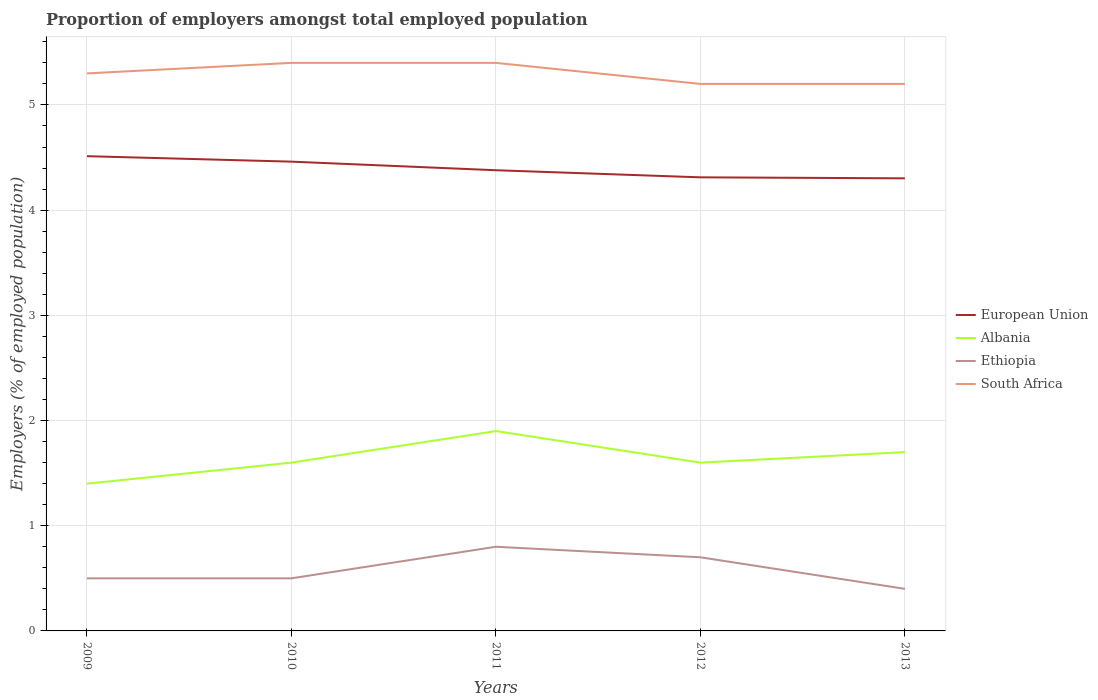How many different coloured lines are there?
Your response must be concise. 4. Across all years, what is the maximum proportion of employers in Albania?
Ensure brevity in your answer.  1.4. In which year was the proportion of employers in Albania maximum?
Your response must be concise. 2009. What is the difference between the highest and the second highest proportion of employers in Albania?
Give a very brief answer. 0.5. Is the proportion of employers in Albania strictly greater than the proportion of employers in South Africa over the years?
Provide a succinct answer. Yes. How many lines are there?
Your answer should be very brief. 4. Are the values on the major ticks of Y-axis written in scientific E-notation?
Ensure brevity in your answer.  No. Does the graph contain any zero values?
Provide a short and direct response. No. Where does the legend appear in the graph?
Ensure brevity in your answer.  Center right. How are the legend labels stacked?
Ensure brevity in your answer.  Vertical. What is the title of the graph?
Provide a short and direct response. Proportion of employers amongst total employed population. Does "Pakistan" appear as one of the legend labels in the graph?
Your response must be concise. No. What is the label or title of the X-axis?
Ensure brevity in your answer.  Years. What is the label or title of the Y-axis?
Ensure brevity in your answer.  Employers (% of employed population). What is the Employers (% of employed population) of European Union in 2009?
Your response must be concise. 4.51. What is the Employers (% of employed population) in Albania in 2009?
Offer a terse response. 1.4. What is the Employers (% of employed population) in Ethiopia in 2009?
Your answer should be very brief. 0.5. What is the Employers (% of employed population) in South Africa in 2009?
Make the answer very short. 5.3. What is the Employers (% of employed population) of European Union in 2010?
Provide a succinct answer. 4.46. What is the Employers (% of employed population) of Albania in 2010?
Your response must be concise. 1.6. What is the Employers (% of employed population) of Ethiopia in 2010?
Offer a terse response. 0.5. What is the Employers (% of employed population) of South Africa in 2010?
Your answer should be compact. 5.4. What is the Employers (% of employed population) in European Union in 2011?
Keep it short and to the point. 4.38. What is the Employers (% of employed population) in Albania in 2011?
Your answer should be very brief. 1.9. What is the Employers (% of employed population) in Ethiopia in 2011?
Give a very brief answer. 0.8. What is the Employers (% of employed population) in South Africa in 2011?
Make the answer very short. 5.4. What is the Employers (% of employed population) of European Union in 2012?
Make the answer very short. 4.31. What is the Employers (% of employed population) in Albania in 2012?
Your response must be concise. 1.6. What is the Employers (% of employed population) in Ethiopia in 2012?
Offer a terse response. 0.7. What is the Employers (% of employed population) in South Africa in 2012?
Provide a succinct answer. 5.2. What is the Employers (% of employed population) of European Union in 2013?
Ensure brevity in your answer.  4.3. What is the Employers (% of employed population) in Albania in 2013?
Give a very brief answer. 1.7. What is the Employers (% of employed population) in Ethiopia in 2013?
Your answer should be compact. 0.4. What is the Employers (% of employed population) in South Africa in 2013?
Offer a terse response. 5.2. Across all years, what is the maximum Employers (% of employed population) of European Union?
Give a very brief answer. 4.51. Across all years, what is the maximum Employers (% of employed population) of Albania?
Provide a short and direct response. 1.9. Across all years, what is the maximum Employers (% of employed population) of Ethiopia?
Offer a very short reply. 0.8. Across all years, what is the maximum Employers (% of employed population) of South Africa?
Your response must be concise. 5.4. Across all years, what is the minimum Employers (% of employed population) in European Union?
Offer a terse response. 4.3. Across all years, what is the minimum Employers (% of employed population) in Albania?
Offer a terse response. 1.4. Across all years, what is the minimum Employers (% of employed population) of Ethiopia?
Your answer should be very brief. 0.4. Across all years, what is the minimum Employers (% of employed population) in South Africa?
Your answer should be very brief. 5.2. What is the total Employers (% of employed population) of European Union in the graph?
Offer a terse response. 21.97. What is the difference between the Employers (% of employed population) of European Union in 2009 and that in 2010?
Your response must be concise. 0.05. What is the difference between the Employers (% of employed population) in Ethiopia in 2009 and that in 2010?
Your answer should be compact. 0. What is the difference between the Employers (% of employed population) of European Union in 2009 and that in 2011?
Make the answer very short. 0.13. What is the difference between the Employers (% of employed population) in Albania in 2009 and that in 2011?
Provide a short and direct response. -0.5. What is the difference between the Employers (% of employed population) in European Union in 2009 and that in 2012?
Provide a succinct answer. 0.2. What is the difference between the Employers (% of employed population) in South Africa in 2009 and that in 2012?
Make the answer very short. 0.1. What is the difference between the Employers (% of employed population) in European Union in 2009 and that in 2013?
Offer a terse response. 0.21. What is the difference between the Employers (% of employed population) of Ethiopia in 2009 and that in 2013?
Give a very brief answer. 0.1. What is the difference between the Employers (% of employed population) in South Africa in 2009 and that in 2013?
Keep it short and to the point. 0.1. What is the difference between the Employers (% of employed population) in European Union in 2010 and that in 2011?
Ensure brevity in your answer.  0.08. What is the difference between the Employers (% of employed population) of Ethiopia in 2010 and that in 2011?
Ensure brevity in your answer.  -0.3. What is the difference between the Employers (% of employed population) of European Union in 2010 and that in 2012?
Offer a very short reply. 0.15. What is the difference between the Employers (% of employed population) of Albania in 2010 and that in 2012?
Your answer should be compact. 0. What is the difference between the Employers (% of employed population) of Ethiopia in 2010 and that in 2012?
Keep it short and to the point. -0.2. What is the difference between the Employers (% of employed population) of European Union in 2010 and that in 2013?
Keep it short and to the point. 0.16. What is the difference between the Employers (% of employed population) in Ethiopia in 2010 and that in 2013?
Your answer should be compact. 0.1. What is the difference between the Employers (% of employed population) of European Union in 2011 and that in 2012?
Make the answer very short. 0.07. What is the difference between the Employers (% of employed population) of South Africa in 2011 and that in 2012?
Keep it short and to the point. 0.2. What is the difference between the Employers (% of employed population) in European Union in 2011 and that in 2013?
Your answer should be very brief. 0.08. What is the difference between the Employers (% of employed population) of South Africa in 2011 and that in 2013?
Offer a terse response. 0.2. What is the difference between the Employers (% of employed population) in European Union in 2012 and that in 2013?
Your answer should be compact. 0.01. What is the difference between the Employers (% of employed population) of Ethiopia in 2012 and that in 2013?
Your answer should be very brief. 0.3. What is the difference between the Employers (% of employed population) in South Africa in 2012 and that in 2013?
Provide a succinct answer. 0. What is the difference between the Employers (% of employed population) in European Union in 2009 and the Employers (% of employed population) in Albania in 2010?
Your response must be concise. 2.91. What is the difference between the Employers (% of employed population) in European Union in 2009 and the Employers (% of employed population) in Ethiopia in 2010?
Your answer should be compact. 4.01. What is the difference between the Employers (% of employed population) in European Union in 2009 and the Employers (% of employed population) in South Africa in 2010?
Your answer should be compact. -0.89. What is the difference between the Employers (% of employed population) in Albania in 2009 and the Employers (% of employed population) in Ethiopia in 2010?
Provide a succinct answer. 0.9. What is the difference between the Employers (% of employed population) in Albania in 2009 and the Employers (% of employed population) in South Africa in 2010?
Offer a terse response. -4. What is the difference between the Employers (% of employed population) in Ethiopia in 2009 and the Employers (% of employed population) in South Africa in 2010?
Provide a succinct answer. -4.9. What is the difference between the Employers (% of employed population) in European Union in 2009 and the Employers (% of employed population) in Albania in 2011?
Give a very brief answer. 2.61. What is the difference between the Employers (% of employed population) of European Union in 2009 and the Employers (% of employed population) of Ethiopia in 2011?
Your answer should be very brief. 3.71. What is the difference between the Employers (% of employed population) of European Union in 2009 and the Employers (% of employed population) of South Africa in 2011?
Provide a short and direct response. -0.89. What is the difference between the Employers (% of employed population) in Albania in 2009 and the Employers (% of employed population) in South Africa in 2011?
Make the answer very short. -4. What is the difference between the Employers (% of employed population) in Ethiopia in 2009 and the Employers (% of employed population) in South Africa in 2011?
Provide a short and direct response. -4.9. What is the difference between the Employers (% of employed population) of European Union in 2009 and the Employers (% of employed population) of Albania in 2012?
Offer a very short reply. 2.91. What is the difference between the Employers (% of employed population) of European Union in 2009 and the Employers (% of employed population) of Ethiopia in 2012?
Offer a very short reply. 3.81. What is the difference between the Employers (% of employed population) of European Union in 2009 and the Employers (% of employed population) of South Africa in 2012?
Keep it short and to the point. -0.69. What is the difference between the Employers (% of employed population) of Ethiopia in 2009 and the Employers (% of employed population) of South Africa in 2012?
Give a very brief answer. -4.7. What is the difference between the Employers (% of employed population) of European Union in 2009 and the Employers (% of employed population) of Albania in 2013?
Ensure brevity in your answer.  2.81. What is the difference between the Employers (% of employed population) in European Union in 2009 and the Employers (% of employed population) in Ethiopia in 2013?
Your answer should be compact. 4.11. What is the difference between the Employers (% of employed population) of European Union in 2009 and the Employers (% of employed population) of South Africa in 2013?
Keep it short and to the point. -0.69. What is the difference between the Employers (% of employed population) in Albania in 2009 and the Employers (% of employed population) in South Africa in 2013?
Your answer should be very brief. -3.8. What is the difference between the Employers (% of employed population) of Ethiopia in 2009 and the Employers (% of employed population) of South Africa in 2013?
Provide a succinct answer. -4.7. What is the difference between the Employers (% of employed population) of European Union in 2010 and the Employers (% of employed population) of Albania in 2011?
Your response must be concise. 2.56. What is the difference between the Employers (% of employed population) in European Union in 2010 and the Employers (% of employed population) in Ethiopia in 2011?
Offer a terse response. 3.66. What is the difference between the Employers (% of employed population) in European Union in 2010 and the Employers (% of employed population) in South Africa in 2011?
Your answer should be compact. -0.94. What is the difference between the Employers (% of employed population) in Albania in 2010 and the Employers (% of employed population) in South Africa in 2011?
Give a very brief answer. -3.8. What is the difference between the Employers (% of employed population) in Ethiopia in 2010 and the Employers (% of employed population) in South Africa in 2011?
Your answer should be compact. -4.9. What is the difference between the Employers (% of employed population) in European Union in 2010 and the Employers (% of employed population) in Albania in 2012?
Keep it short and to the point. 2.86. What is the difference between the Employers (% of employed population) of European Union in 2010 and the Employers (% of employed population) of Ethiopia in 2012?
Offer a very short reply. 3.76. What is the difference between the Employers (% of employed population) of European Union in 2010 and the Employers (% of employed population) of South Africa in 2012?
Your response must be concise. -0.74. What is the difference between the Employers (% of employed population) in Albania in 2010 and the Employers (% of employed population) in Ethiopia in 2012?
Give a very brief answer. 0.9. What is the difference between the Employers (% of employed population) of Albania in 2010 and the Employers (% of employed population) of South Africa in 2012?
Provide a succinct answer. -3.6. What is the difference between the Employers (% of employed population) of European Union in 2010 and the Employers (% of employed population) of Albania in 2013?
Provide a succinct answer. 2.76. What is the difference between the Employers (% of employed population) of European Union in 2010 and the Employers (% of employed population) of Ethiopia in 2013?
Provide a succinct answer. 4.06. What is the difference between the Employers (% of employed population) in European Union in 2010 and the Employers (% of employed population) in South Africa in 2013?
Give a very brief answer. -0.74. What is the difference between the Employers (% of employed population) of Albania in 2010 and the Employers (% of employed population) of South Africa in 2013?
Give a very brief answer. -3.6. What is the difference between the Employers (% of employed population) of Ethiopia in 2010 and the Employers (% of employed population) of South Africa in 2013?
Offer a very short reply. -4.7. What is the difference between the Employers (% of employed population) in European Union in 2011 and the Employers (% of employed population) in Albania in 2012?
Offer a terse response. 2.78. What is the difference between the Employers (% of employed population) in European Union in 2011 and the Employers (% of employed population) in Ethiopia in 2012?
Ensure brevity in your answer.  3.68. What is the difference between the Employers (% of employed population) of European Union in 2011 and the Employers (% of employed population) of South Africa in 2012?
Provide a succinct answer. -0.82. What is the difference between the Employers (% of employed population) in Ethiopia in 2011 and the Employers (% of employed population) in South Africa in 2012?
Provide a succinct answer. -4.4. What is the difference between the Employers (% of employed population) of European Union in 2011 and the Employers (% of employed population) of Albania in 2013?
Offer a terse response. 2.68. What is the difference between the Employers (% of employed population) in European Union in 2011 and the Employers (% of employed population) in Ethiopia in 2013?
Ensure brevity in your answer.  3.98. What is the difference between the Employers (% of employed population) of European Union in 2011 and the Employers (% of employed population) of South Africa in 2013?
Ensure brevity in your answer.  -0.82. What is the difference between the Employers (% of employed population) of Albania in 2011 and the Employers (% of employed population) of Ethiopia in 2013?
Provide a short and direct response. 1.5. What is the difference between the Employers (% of employed population) of European Union in 2012 and the Employers (% of employed population) of Albania in 2013?
Your response must be concise. 2.61. What is the difference between the Employers (% of employed population) of European Union in 2012 and the Employers (% of employed population) of Ethiopia in 2013?
Ensure brevity in your answer.  3.91. What is the difference between the Employers (% of employed population) in European Union in 2012 and the Employers (% of employed population) in South Africa in 2013?
Your response must be concise. -0.89. What is the difference between the Employers (% of employed population) in Albania in 2012 and the Employers (% of employed population) in Ethiopia in 2013?
Offer a terse response. 1.2. What is the difference between the Employers (% of employed population) of Albania in 2012 and the Employers (% of employed population) of South Africa in 2013?
Keep it short and to the point. -3.6. What is the average Employers (% of employed population) in European Union per year?
Ensure brevity in your answer.  4.39. What is the average Employers (% of employed population) in Albania per year?
Offer a terse response. 1.64. What is the average Employers (% of employed population) in Ethiopia per year?
Ensure brevity in your answer.  0.58. In the year 2009, what is the difference between the Employers (% of employed population) of European Union and Employers (% of employed population) of Albania?
Offer a very short reply. 3.11. In the year 2009, what is the difference between the Employers (% of employed population) in European Union and Employers (% of employed population) in Ethiopia?
Ensure brevity in your answer.  4.01. In the year 2009, what is the difference between the Employers (% of employed population) of European Union and Employers (% of employed population) of South Africa?
Provide a succinct answer. -0.79. In the year 2009, what is the difference between the Employers (% of employed population) of Albania and Employers (% of employed population) of South Africa?
Offer a terse response. -3.9. In the year 2009, what is the difference between the Employers (% of employed population) of Ethiopia and Employers (% of employed population) of South Africa?
Offer a terse response. -4.8. In the year 2010, what is the difference between the Employers (% of employed population) in European Union and Employers (% of employed population) in Albania?
Make the answer very short. 2.86. In the year 2010, what is the difference between the Employers (% of employed population) of European Union and Employers (% of employed population) of Ethiopia?
Ensure brevity in your answer.  3.96. In the year 2010, what is the difference between the Employers (% of employed population) of European Union and Employers (% of employed population) of South Africa?
Your response must be concise. -0.94. In the year 2010, what is the difference between the Employers (% of employed population) in Ethiopia and Employers (% of employed population) in South Africa?
Keep it short and to the point. -4.9. In the year 2011, what is the difference between the Employers (% of employed population) of European Union and Employers (% of employed population) of Albania?
Give a very brief answer. 2.48. In the year 2011, what is the difference between the Employers (% of employed population) of European Union and Employers (% of employed population) of Ethiopia?
Keep it short and to the point. 3.58. In the year 2011, what is the difference between the Employers (% of employed population) of European Union and Employers (% of employed population) of South Africa?
Provide a succinct answer. -1.02. In the year 2011, what is the difference between the Employers (% of employed population) in Albania and Employers (% of employed population) in Ethiopia?
Provide a succinct answer. 1.1. In the year 2011, what is the difference between the Employers (% of employed population) in Albania and Employers (% of employed population) in South Africa?
Make the answer very short. -3.5. In the year 2012, what is the difference between the Employers (% of employed population) in European Union and Employers (% of employed population) in Albania?
Ensure brevity in your answer.  2.71. In the year 2012, what is the difference between the Employers (% of employed population) of European Union and Employers (% of employed population) of Ethiopia?
Provide a short and direct response. 3.61. In the year 2012, what is the difference between the Employers (% of employed population) of European Union and Employers (% of employed population) of South Africa?
Your response must be concise. -0.89. In the year 2012, what is the difference between the Employers (% of employed population) of Albania and Employers (% of employed population) of Ethiopia?
Ensure brevity in your answer.  0.9. In the year 2013, what is the difference between the Employers (% of employed population) in European Union and Employers (% of employed population) in Albania?
Your answer should be very brief. 2.6. In the year 2013, what is the difference between the Employers (% of employed population) of European Union and Employers (% of employed population) of Ethiopia?
Provide a short and direct response. 3.9. In the year 2013, what is the difference between the Employers (% of employed population) of European Union and Employers (% of employed population) of South Africa?
Provide a succinct answer. -0.9. In the year 2013, what is the difference between the Employers (% of employed population) of Albania and Employers (% of employed population) of Ethiopia?
Your answer should be very brief. 1.3. In the year 2013, what is the difference between the Employers (% of employed population) of Albania and Employers (% of employed population) of South Africa?
Keep it short and to the point. -3.5. In the year 2013, what is the difference between the Employers (% of employed population) in Ethiopia and Employers (% of employed population) in South Africa?
Provide a short and direct response. -4.8. What is the ratio of the Employers (% of employed population) of European Union in 2009 to that in 2010?
Your response must be concise. 1.01. What is the ratio of the Employers (% of employed population) of Albania in 2009 to that in 2010?
Provide a succinct answer. 0.88. What is the ratio of the Employers (% of employed population) of South Africa in 2009 to that in 2010?
Make the answer very short. 0.98. What is the ratio of the Employers (% of employed population) of European Union in 2009 to that in 2011?
Make the answer very short. 1.03. What is the ratio of the Employers (% of employed population) in Albania in 2009 to that in 2011?
Offer a very short reply. 0.74. What is the ratio of the Employers (% of employed population) in Ethiopia in 2009 to that in 2011?
Provide a succinct answer. 0.62. What is the ratio of the Employers (% of employed population) of South Africa in 2009 to that in 2011?
Make the answer very short. 0.98. What is the ratio of the Employers (% of employed population) in European Union in 2009 to that in 2012?
Your answer should be very brief. 1.05. What is the ratio of the Employers (% of employed population) of Ethiopia in 2009 to that in 2012?
Provide a succinct answer. 0.71. What is the ratio of the Employers (% of employed population) of South Africa in 2009 to that in 2012?
Provide a short and direct response. 1.02. What is the ratio of the Employers (% of employed population) in European Union in 2009 to that in 2013?
Your answer should be compact. 1.05. What is the ratio of the Employers (% of employed population) in Albania in 2009 to that in 2013?
Make the answer very short. 0.82. What is the ratio of the Employers (% of employed population) of South Africa in 2009 to that in 2013?
Your answer should be compact. 1.02. What is the ratio of the Employers (% of employed population) of European Union in 2010 to that in 2011?
Your answer should be compact. 1.02. What is the ratio of the Employers (% of employed population) in Albania in 2010 to that in 2011?
Ensure brevity in your answer.  0.84. What is the ratio of the Employers (% of employed population) in Ethiopia in 2010 to that in 2011?
Your answer should be compact. 0.62. What is the ratio of the Employers (% of employed population) in European Union in 2010 to that in 2012?
Provide a succinct answer. 1.03. What is the ratio of the Employers (% of employed population) in European Union in 2010 to that in 2013?
Provide a short and direct response. 1.04. What is the ratio of the Employers (% of employed population) of Albania in 2010 to that in 2013?
Ensure brevity in your answer.  0.94. What is the ratio of the Employers (% of employed population) in Ethiopia in 2010 to that in 2013?
Your response must be concise. 1.25. What is the ratio of the Employers (% of employed population) of European Union in 2011 to that in 2012?
Offer a terse response. 1.02. What is the ratio of the Employers (% of employed population) of Albania in 2011 to that in 2012?
Your answer should be compact. 1.19. What is the ratio of the Employers (% of employed population) in South Africa in 2011 to that in 2012?
Provide a short and direct response. 1.04. What is the ratio of the Employers (% of employed population) in European Union in 2011 to that in 2013?
Keep it short and to the point. 1.02. What is the ratio of the Employers (% of employed population) of Albania in 2011 to that in 2013?
Offer a terse response. 1.12. What is the ratio of the Employers (% of employed population) in Ethiopia in 2011 to that in 2013?
Provide a succinct answer. 2. What is the ratio of the Employers (% of employed population) of European Union in 2012 to that in 2013?
Keep it short and to the point. 1. What is the ratio of the Employers (% of employed population) of Albania in 2012 to that in 2013?
Keep it short and to the point. 0.94. What is the ratio of the Employers (% of employed population) of Ethiopia in 2012 to that in 2013?
Offer a very short reply. 1.75. What is the ratio of the Employers (% of employed population) in South Africa in 2012 to that in 2013?
Provide a short and direct response. 1. What is the difference between the highest and the second highest Employers (% of employed population) in European Union?
Offer a very short reply. 0.05. What is the difference between the highest and the second highest Employers (% of employed population) in Albania?
Keep it short and to the point. 0.2. What is the difference between the highest and the lowest Employers (% of employed population) of European Union?
Make the answer very short. 0.21. What is the difference between the highest and the lowest Employers (% of employed population) in Albania?
Offer a very short reply. 0.5. What is the difference between the highest and the lowest Employers (% of employed population) in South Africa?
Your response must be concise. 0.2. 